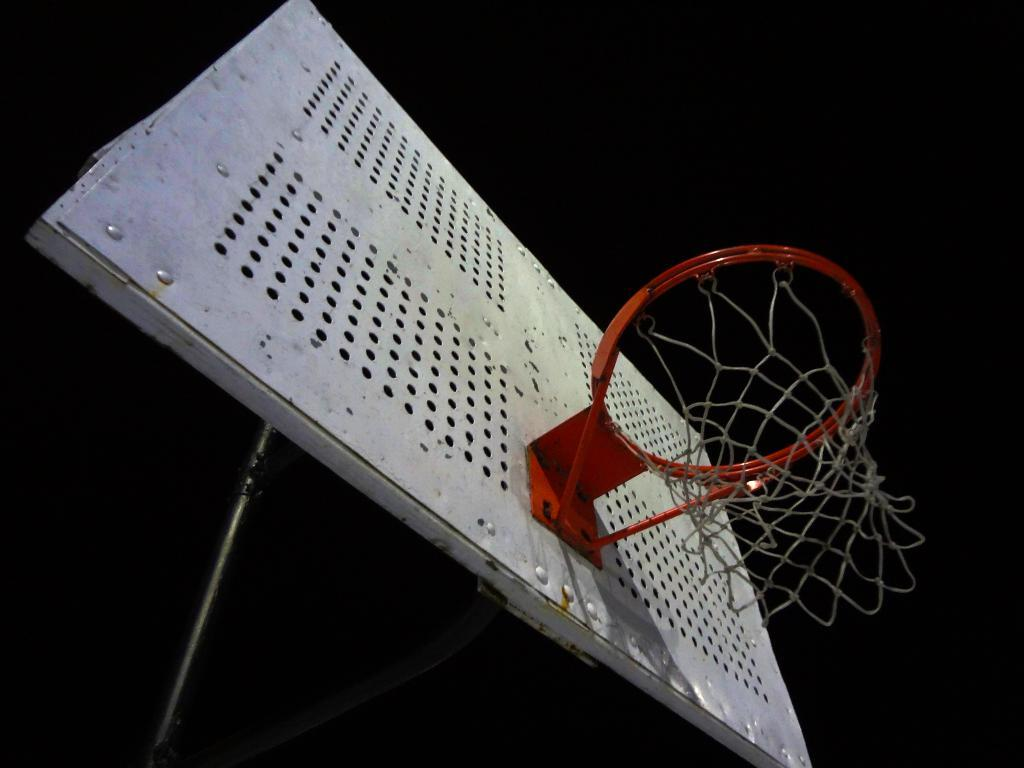What is the main object in the image? There is a basketball hoop in the image. What other objects can be seen in the image? There are rods visible in the image. Can you describe the background of the image? The background of the image appears to be dark. Where is the basin located in the image? There is no basin present in the image. What type of order is being followed in the image? The image does not depict any specific order or process. 